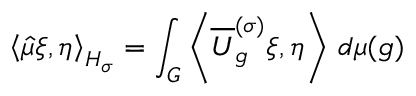<formula> <loc_0><loc_0><loc_500><loc_500>\left \langle { \hat { \mu } } \xi , \eta \right \rangle _ { H _ { \sigma } } = \int _ { G } \left \langle { \overline { U } } _ { g } ^ { ( \sigma ) } \xi , \eta \right \rangle \, d \mu ( g )</formula> 